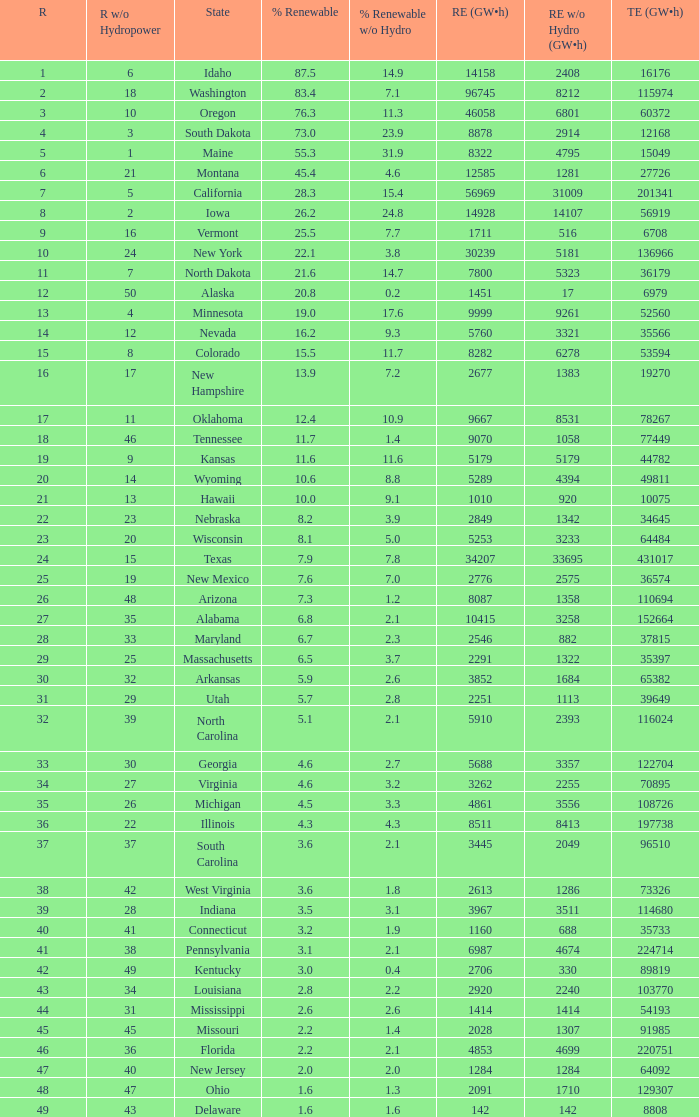Which state has 5179 (gw×h) of renewable energy without hydrogen power?wha Kansas. 